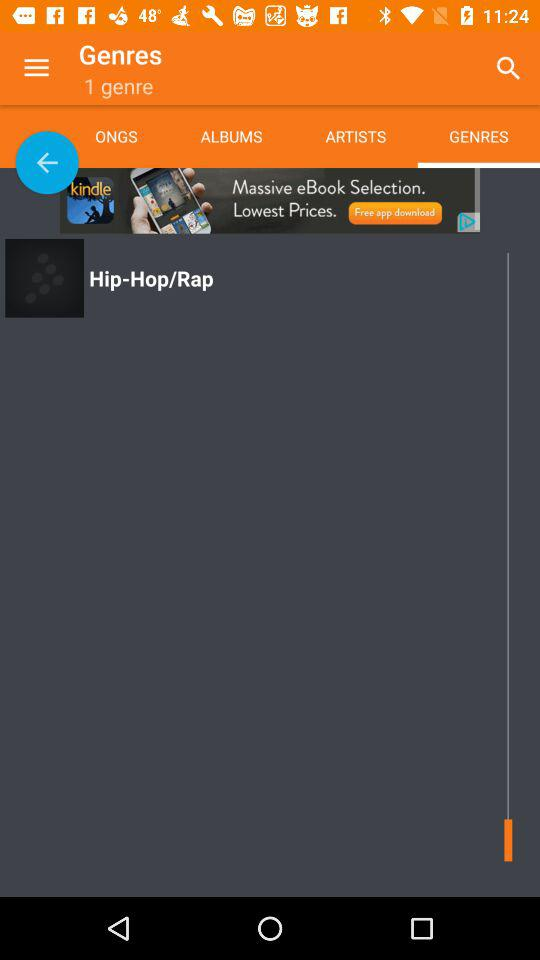What is the name of the genre? The name of the genre is "Hip-Hop/Rap". 